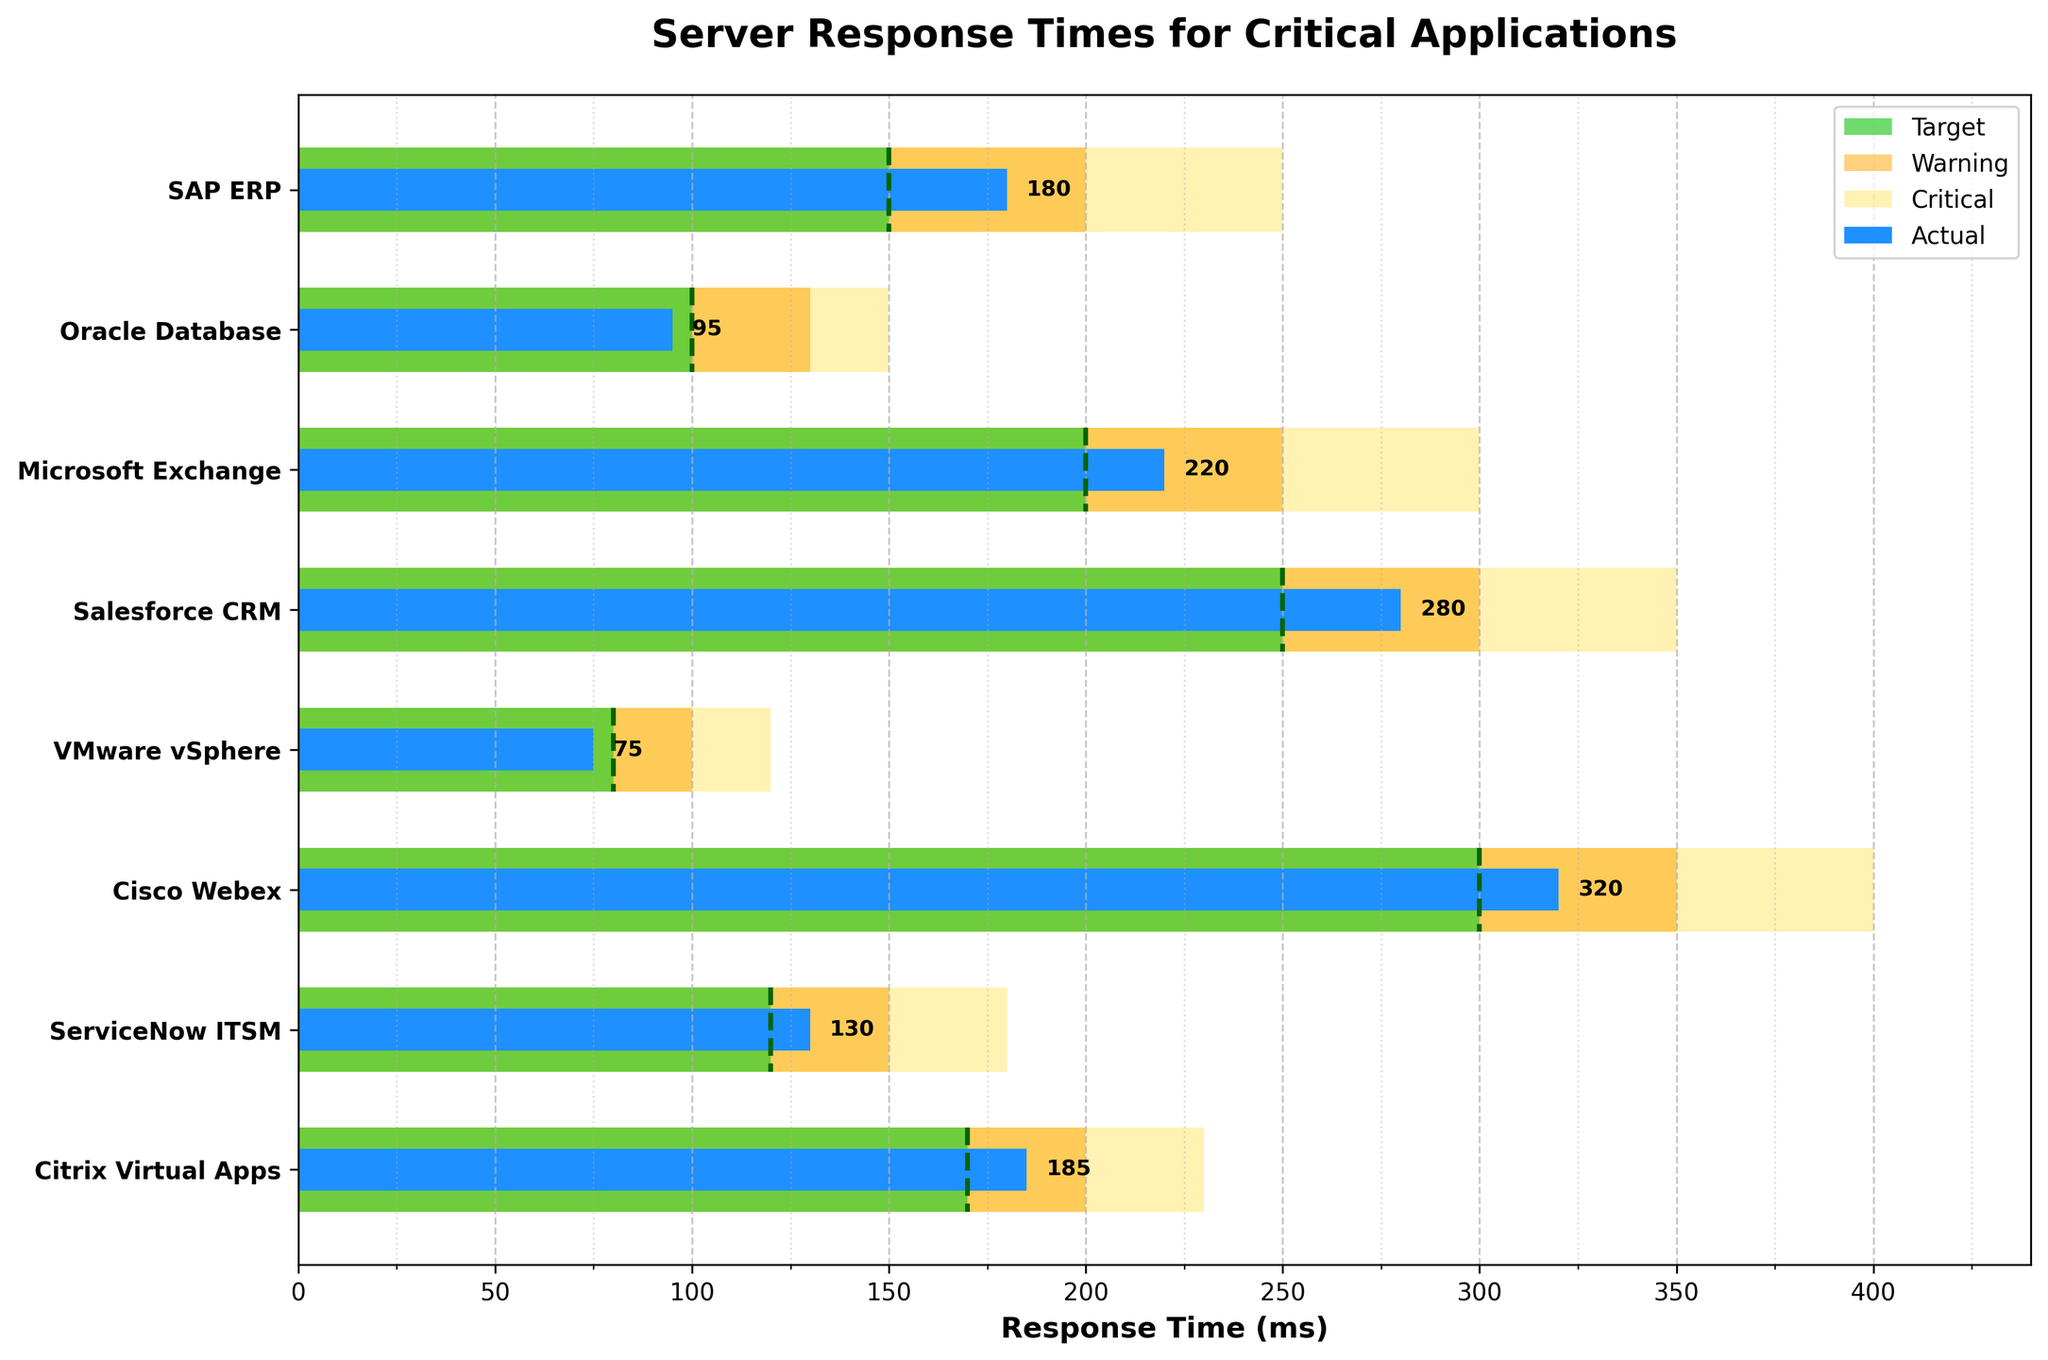What is the title of the chart? The title of the chart is typically located at the top and is bolded. In this case, it reads "Server Response Times for Critical Applications."
Answer: Server Response Times for Critical Applications Which application has the highest actual response time? To find the highest actual response time, look for the longest bar colored in blue. In this case, it is "Cisco Webex" with an actual response time of 320 ms.
Answer: Cisco Webex How many applications have an actual response time that exceeds their target response time? Count the number of blue bars that extend beyond the green background bars representing target response times. The applications are: SAP ERP, Microsoft Exchange, Salesforce CRM, Cisco Webex, ServiceNow ITSM, and Citrix Virtual Apps.
Answer: 6 What is the target response time for Salesforce CRM? The target response time can be identified by the green background bar and verified by the vertical dashed line. For Salesforce CRM, it is 250 ms.
Answer: 250 ms Which applications fall within the warning threshold but do not reach the critical threshold for their response times? Look at the orange background bars and identify which blue bars remain within this range but do not extend into the yellow background bars. These applications are Microsoft Exchange and Salesforce CRM.
Answer: Microsoft Exchange, Salesforce CRM How does the actual response time of VMware vSphere compare to its target response time? Compare the length of the blue bar (actual) to the green bar (target). For VMware vSphere, the actual response time of 75 ms is below the target response time of 80 ms.
Answer: Below Which application is performing best in terms of meeting or exceeding its target response time? The best-performing application will have its blue bar entirely within or below the green bar. VMware vSphere has an actual response time of 75 ms, below the target of 80 ms.
Answer: VMware vSphere What is the average actual response time for all applications? Sum the actual response times and divide by the number of applications. The actual response times are: 180, 95, 220, 280, 75, 320, 130, 185. The total is 1485. Dividing by 8 gives 185.625 ms.
Answer: 185.625 ms Which application has an actual response time closest to its warning threshold? Find the application where the blue bar (actual response time) is nearest to but does not exceed the orange bar (warning threshold). It is ServiceNow ITSM with an actual response time of 130 ms and a warning threshold of 150 ms.
Answer: ServiceNow ITSM 